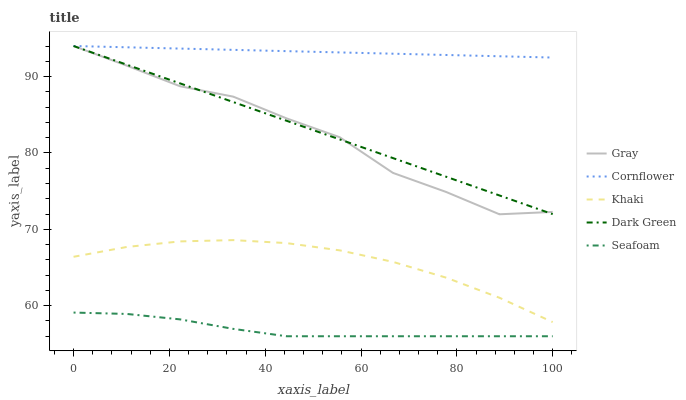Does Seafoam have the minimum area under the curve?
Answer yes or no. Yes. Does Cornflower have the maximum area under the curve?
Answer yes or no. Yes. Does Khaki have the minimum area under the curve?
Answer yes or no. No. Does Khaki have the maximum area under the curve?
Answer yes or no. No. Is Cornflower the smoothest?
Answer yes or no. Yes. Is Gray the roughest?
Answer yes or no. Yes. Is Khaki the smoothest?
Answer yes or no. No. Is Khaki the roughest?
Answer yes or no. No. Does Seafoam have the lowest value?
Answer yes or no. Yes. Does Khaki have the lowest value?
Answer yes or no. No. Does Cornflower have the highest value?
Answer yes or no. Yes. Does Khaki have the highest value?
Answer yes or no. No. Is Seafoam less than Dark Green?
Answer yes or no. Yes. Is Dark Green greater than Seafoam?
Answer yes or no. Yes. Does Gray intersect Dark Green?
Answer yes or no. Yes. Is Gray less than Dark Green?
Answer yes or no. No. Is Gray greater than Dark Green?
Answer yes or no. No. Does Seafoam intersect Dark Green?
Answer yes or no. No. 